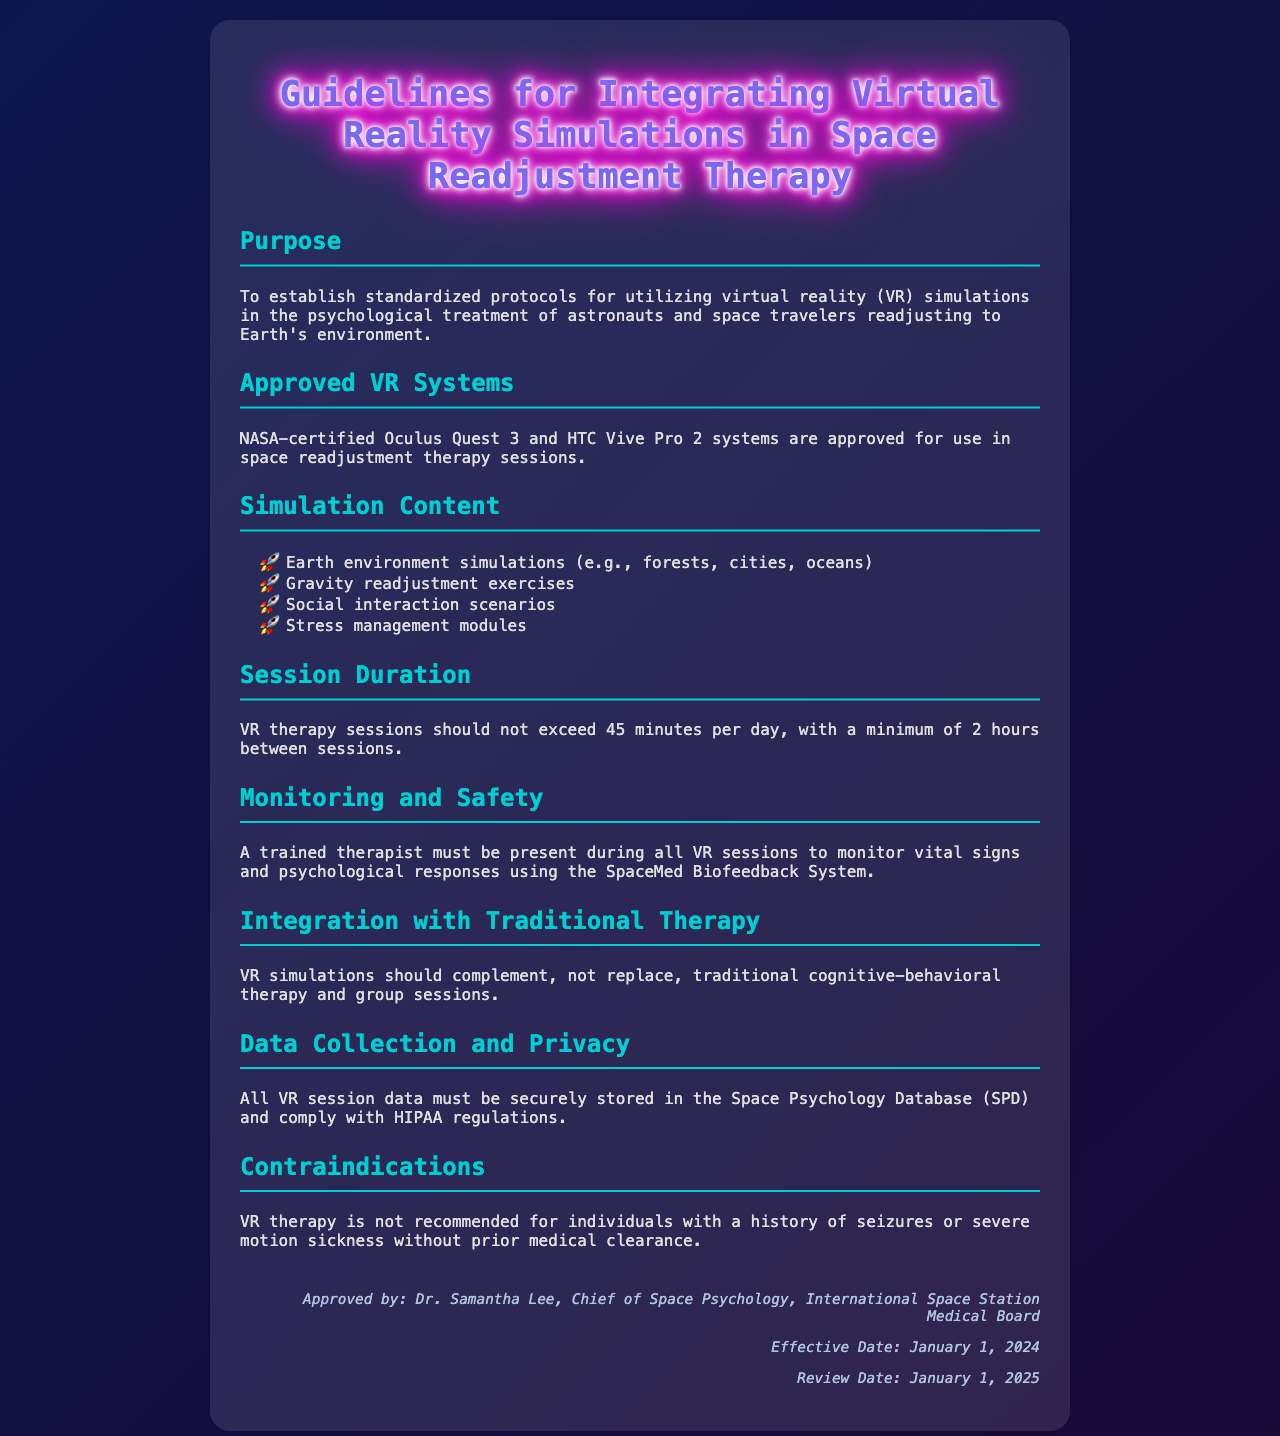What are the approved VR systems? The document states that NASA-certified Oculus Quest 3 and HTC Vive Pro 2 systems are approved for use.
Answer: Oculus Quest 3 and HTC Vive Pro 2 What is the maximum duration for VR therapy sessions? The document specifies that VR therapy sessions should not exceed 45 minutes per day.
Answer: 45 minutes Who must be present during VR sessions? The guidelines indicate that a trained therapist must be present during all VR sessions.
Answer: A trained therapist What types of content are included in the simulations? The document lists Earth environment simulations, gravity readjustment exercises, social interaction scenarios, and stress management modules as content types.
Answer: Earth environment simulations, gravity readjustment exercises, social interaction scenarios, stress management modules What is the purpose of these guidelines? The purpose is to establish standardized protocols for utilizing virtual reality simulations in therapy for astronauts and space travelers.
Answer: To establish standardized protocols What is the effective date of the guidelines? The document specifies that the effective date is January 1, 2024.
Answer: January 1, 2024 What database must VR session data comply with? The guidelines state that all VR session data must be securely stored in the Space Psychology Database (SPD).
Answer: Space Psychology Database (SPD) What are the contraindications for VR therapy? The document mentions that VR therapy is not recommended for individuals with a history of seizures or severe motion sickness.
Answer: History of seizures or severe motion sickness 